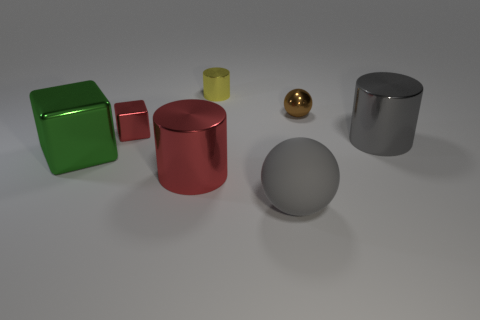Subtract all large gray metal cylinders. How many cylinders are left? 2 Subtract all brown spheres. How many spheres are left? 1 Subtract all blocks. How many objects are left? 5 Subtract 2 cubes. How many cubes are left? 0 Add 7 metallic cylinders. How many metallic cylinders are left? 10 Add 1 cylinders. How many cylinders exist? 4 Add 1 big yellow blocks. How many objects exist? 8 Subtract 0 blue cylinders. How many objects are left? 7 Subtract all red balls. Subtract all purple cylinders. How many balls are left? 2 Subtract all cyan spheres. How many red blocks are left? 1 